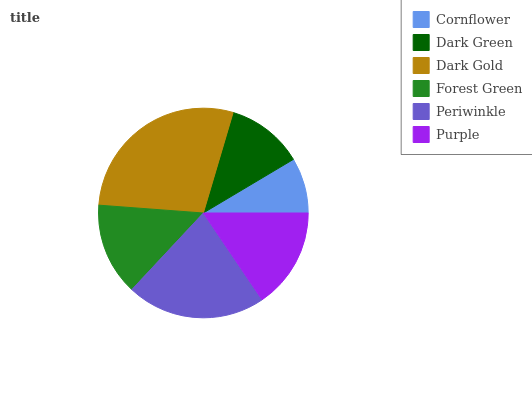Is Cornflower the minimum?
Answer yes or no. Yes. Is Dark Gold the maximum?
Answer yes or no. Yes. Is Dark Green the minimum?
Answer yes or no. No. Is Dark Green the maximum?
Answer yes or no. No. Is Dark Green greater than Cornflower?
Answer yes or no. Yes. Is Cornflower less than Dark Green?
Answer yes or no. Yes. Is Cornflower greater than Dark Green?
Answer yes or no. No. Is Dark Green less than Cornflower?
Answer yes or no. No. Is Purple the high median?
Answer yes or no. Yes. Is Forest Green the low median?
Answer yes or no. Yes. Is Dark Green the high median?
Answer yes or no. No. Is Purple the low median?
Answer yes or no. No. 